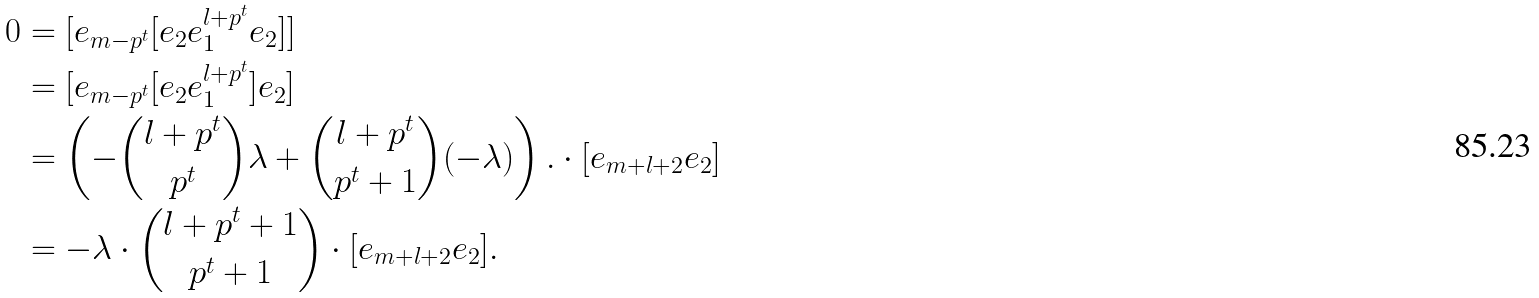<formula> <loc_0><loc_0><loc_500><loc_500>0 & = [ e _ { m - p ^ { t } } [ e _ { 2 } e _ { 1 } ^ { l + p ^ { t } } e _ { 2 } ] ] \\ & = [ e _ { m - p ^ { t } } [ e _ { 2 } e _ { 1 } ^ { l + p ^ { t } } ] e _ { 2 } ] \\ & = \left ( - \binom { l + p ^ { t } } { p ^ { t } } \lambda + \binom { l + p ^ { t } } { p ^ { t } + 1 } ( - \lambda ) \right ) . \cdot [ e _ { m + l + 2 } e _ { 2 } ] \\ & = - \lambda \cdot \binom { l + p ^ { t } + 1 } { p ^ { t } + 1 } \cdot [ e _ { m + l + 2 } e _ { 2 } ] .</formula> 